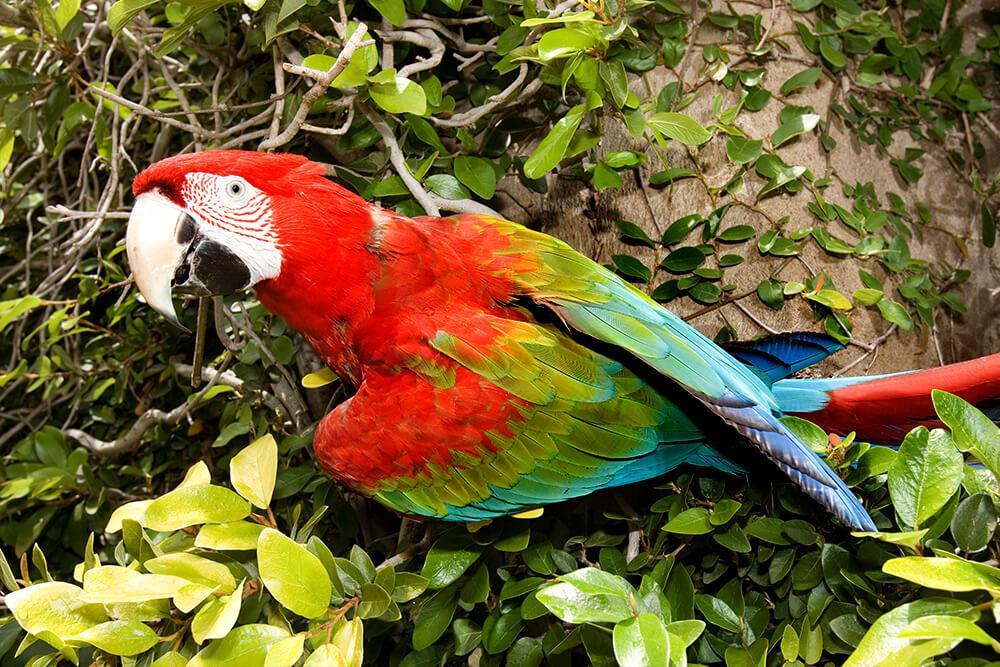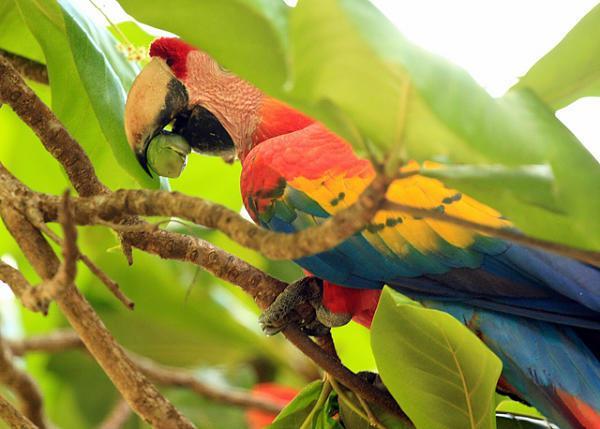The first image is the image on the left, the second image is the image on the right. Considering the images on both sides, is "Each image shows a single parrot surrounded by leafy green foliage, and all parrots have heads angled leftward." valid? Answer yes or no. Yes. The first image is the image on the left, the second image is the image on the right. Evaluate the accuracy of this statement regarding the images: "One macaw is not eating anything.". Is it true? Answer yes or no. Yes. 